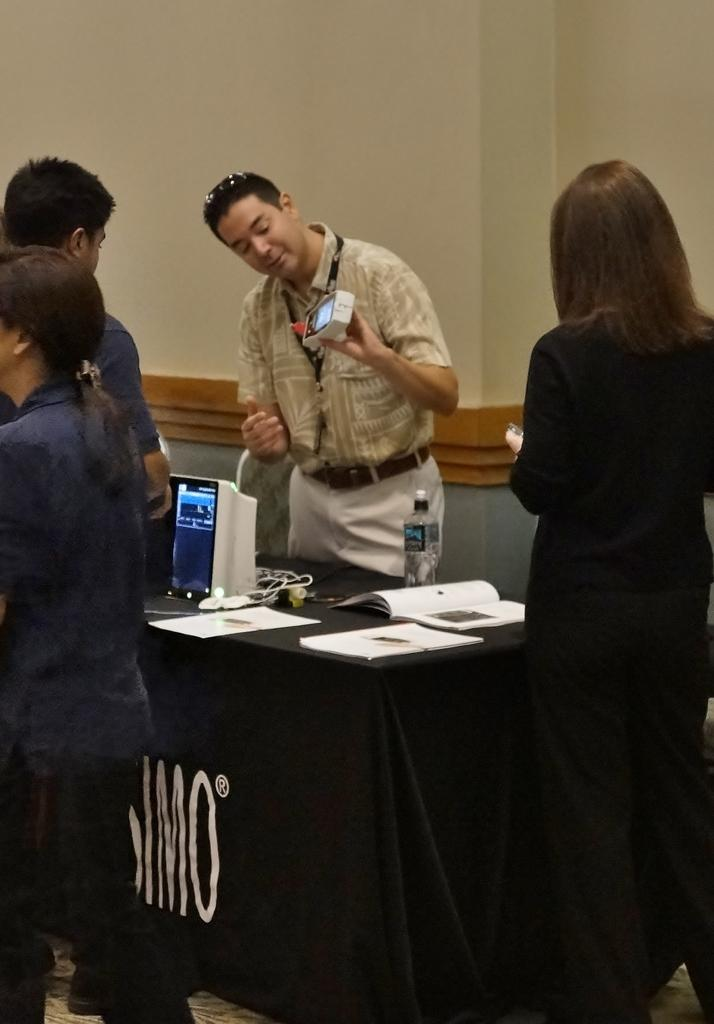Who is the main subject in the image? There is a man in the image. What is the man doing in the image? The man is showing a machine. Who is the man presenting the machine to? There is an audience in front of the man. What type of bread can be seen in the oven in the image? There is no oven or bread present in the image. What color is the hat the man is wearing in the image? The man is not wearing a hat in the image. 